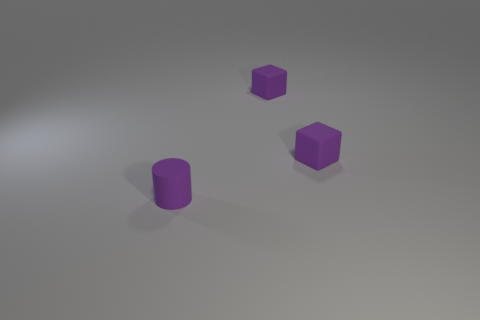Are there more cylinders that are behind the rubber cylinder than big red matte cubes?
Your answer should be compact. No. Are there any other things that are the same material as the small purple cylinder?
Make the answer very short. Yes. The small cylinder has what color?
Keep it short and to the point. Purple. What number of other objects are there of the same size as the purple rubber cylinder?
Keep it short and to the point. 2. Is there another tiny rubber cylinder that has the same color as the rubber cylinder?
Your answer should be very brief. No. How many tiny objects are either purple objects or purple cubes?
Your answer should be very brief. 3. How many purple cubes are there?
Your answer should be compact. 2. Are there any purple objects in front of the tiny purple matte cylinder?
Offer a terse response. No. What number of cubes are made of the same material as the small cylinder?
Provide a short and direct response. 2. What number of metal things are small purple things or gray balls?
Offer a very short reply. 0. 